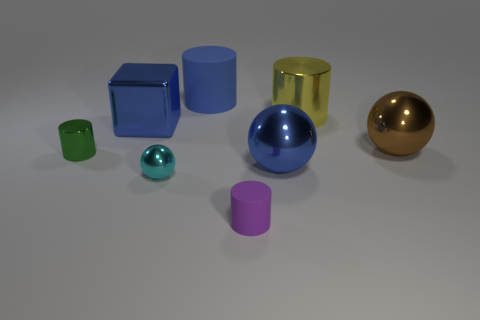What number of large yellow metal things are the same shape as the cyan metal object? There are no large yellow metal objects that share the same shape as the cyan metal object, which is spherical. The large yellow object is cylindrical, not spherical. 